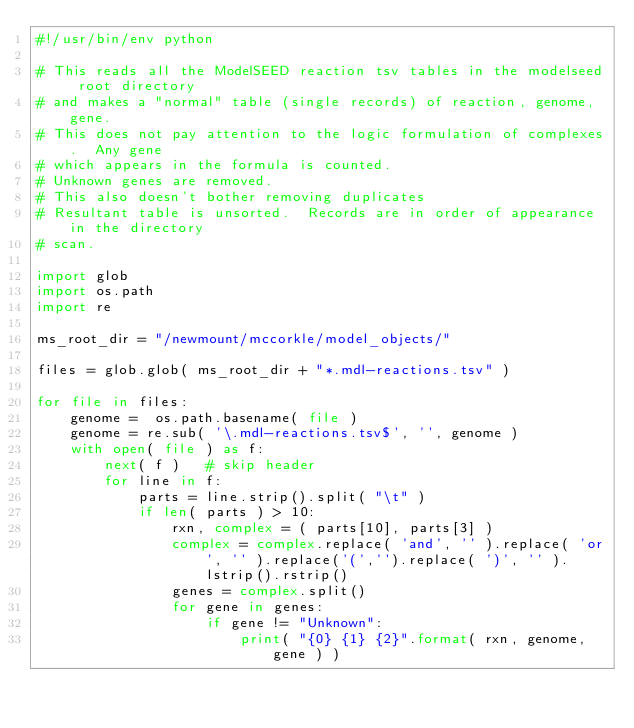Convert code to text. <code><loc_0><loc_0><loc_500><loc_500><_Python_>#!/usr/bin/env python

# This reads all the ModelSEED reaction tsv tables in the modelseed root directory 
# and makes a "normal" table (single records) of reaction, genome, gene.
# This does not pay attention to the logic formulation of complexes.  Any gene
# which appears in the formula is counted.
# Unknown genes are removed.
# This also doesn't bother removing duplicates
# Resultant table is unsorted.  Records are in order of appearance in the directory
# scan.

import glob
import os.path
import re

ms_root_dir = "/newmount/mccorkle/model_objects/"

files = glob.glob( ms_root_dir + "*.mdl-reactions.tsv" )

for file in files:
    genome =  os.path.basename( file )
    genome = re.sub( '\.mdl-reactions.tsv$', '', genome )
    with open( file ) as f:
        next( f )   # skip header
        for line in f:
            parts = line.strip().split( "\t" )
            if len( parts ) > 10:
                rxn, complex = ( parts[10], parts[3] )
                complex = complex.replace( 'and', '' ).replace( 'or', '' ).replace('(','').replace( ')', '' ).lstrip().rstrip()
                genes = complex.split()
                for gene in genes:
                    if gene != "Unknown":
                        print( "{0} {1} {2}".format( rxn, genome, gene ) )


</code> 